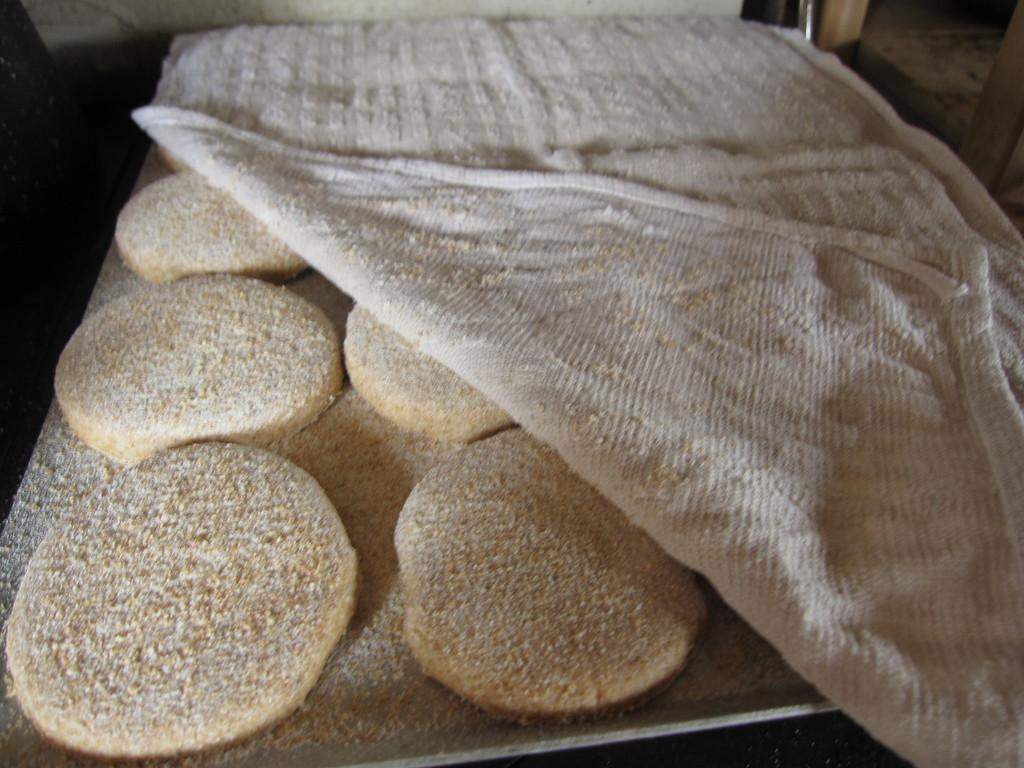What type of food can be seen in the image? There are cookies in the image. How are the cookies arranged or presented? The cookies are on a tray. Is there any covering or protection for the cookies? Yes, the cookies are covered with a white cloth. What type of vest is being worn by the leather representative in the image? There is no vest, leather, or representative present in the image; it only features cookies on a tray covered with a white cloth. 